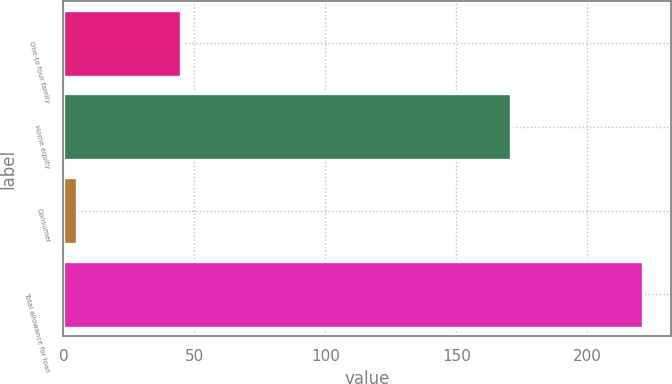<chart> <loc_0><loc_0><loc_500><loc_500><bar_chart><fcel>One-to four family<fcel>Home equity<fcel>Consumer<fcel>Total allowance for loan<nl><fcel>45<fcel>171<fcel>5<fcel>221<nl></chart> 